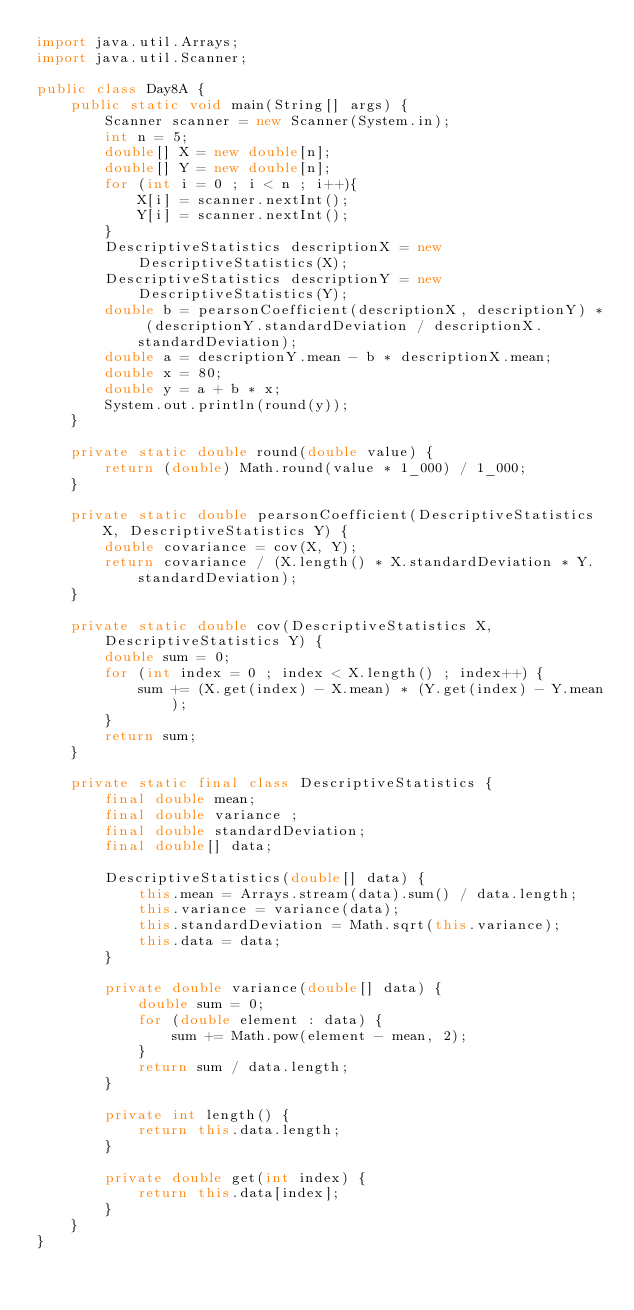Convert code to text. <code><loc_0><loc_0><loc_500><loc_500><_Java_>import java.util.Arrays;
import java.util.Scanner;

public class Day8A {
    public static void main(String[] args) {
        Scanner scanner = new Scanner(System.in);
        int n = 5;
        double[] X = new double[n];
        double[] Y = new double[n];
        for (int i = 0 ; i < n ; i++){
            X[i] = scanner.nextInt();
            Y[i] = scanner.nextInt();
        }
        DescriptiveStatistics descriptionX = new DescriptiveStatistics(X);
        DescriptiveStatistics descriptionY = new DescriptiveStatistics(Y);
        double b = pearsonCoefficient(descriptionX, descriptionY) * (descriptionY.standardDeviation / descriptionX.standardDeviation);
        double a = descriptionY.mean - b * descriptionX.mean;
        double x = 80;
        double y = a + b * x;
        System.out.println(round(y));
    }

    private static double round(double value) {
        return (double) Math.round(value * 1_000) / 1_000;
    }

    private static double pearsonCoefficient(DescriptiveStatistics X, DescriptiveStatistics Y) {
        double covariance = cov(X, Y);
        return covariance / (X.length() * X.standardDeviation * Y.standardDeviation);
    }

    private static double cov(DescriptiveStatistics X, DescriptiveStatistics Y) {
        double sum = 0;
        for (int index = 0 ; index < X.length() ; index++) {
            sum += (X.get(index) - X.mean) * (Y.get(index) - Y.mean);
        }
        return sum;
    }

    private static final class DescriptiveStatistics {
        final double mean;
        final double variance ;
        final double standardDeviation;
        final double[] data;

        DescriptiveStatistics(double[] data) {
            this.mean = Arrays.stream(data).sum() / data.length;
            this.variance = variance(data);
            this.standardDeviation = Math.sqrt(this.variance);
            this.data = data;
        }

        private double variance(double[] data) {
            double sum = 0;
            for (double element : data) {
                sum += Math.pow(element - mean, 2);
            }
            return sum / data.length;
        }

        private int length() {
            return this.data.length;
        }

        private double get(int index) {
            return this.data[index];
        }
    }
}
</code> 